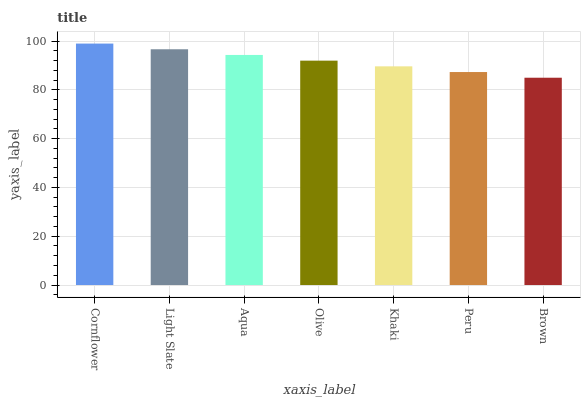Is Brown the minimum?
Answer yes or no. Yes. Is Cornflower the maximum?
Answer yes or no. Yes. Is Light Slate the minimum?
Answer yes or no. No. Is Light Slate the maximum?
Answer yes or no. No. Is Cornflower greater than Light Slate?
Answer yes or no. Yes. Is Light Slate less than Cornflower?
Answer yes or no. Yes. Is Light Slate greater than Cornflower?
Answer yes or no. No. Is Cornflower less than Light Slate?
Answer yes or no. No. Is Olive the high median?
Answer yes or no. Yes. Is Olive the low median?
Answer yes or no. Yes. Is Peru the high median?
Answer yes or no. No. Is Khaki the low median?
Answer yes or no. No. 